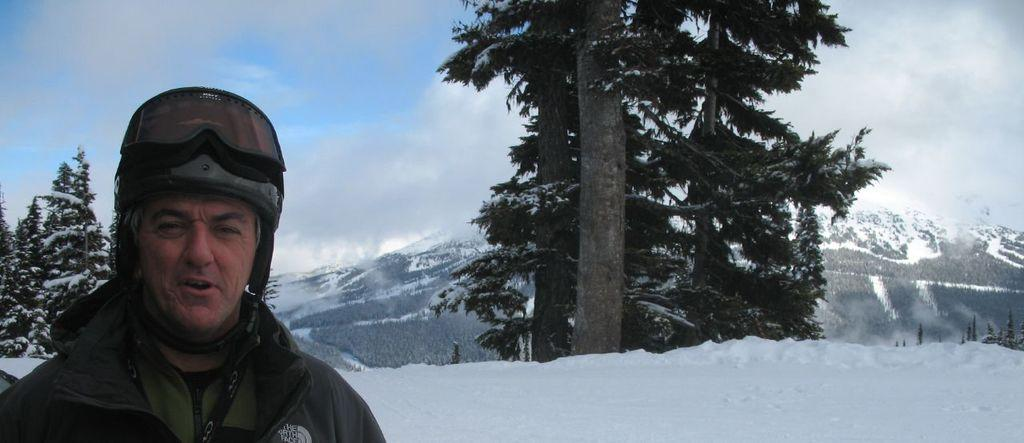What is the person in the image standing on? The person is standing on the snow on the left side of the image. What can be seen in the distance behind the person? There are mountains, snow, trees, and the sky visible in the background of the image. Are there any clouds in the sky? Yes, clouds are present in the sky. What type of shop can be seen in the image? There is no shop present in the image; it features a person standing on snow with mountains, snow, trees, and the sky visible in the background. What color are the person's teeth in the image? There is no visible person's teeth in the image. 